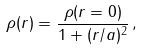Convert formula to latex. <formula><loc_0><loc_0><loc_500><loc_500>\rho ( r ) = \frac { \rho ( r = 0 ) } { 1 + ( r / a ) ^ { 2 } } \, ,</formula> 